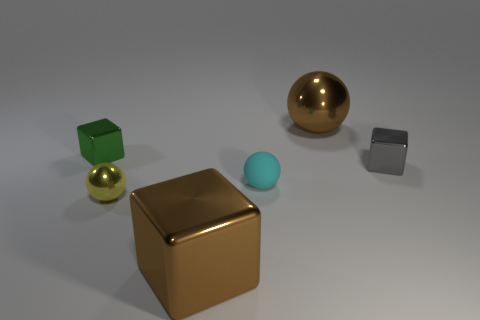Is the number of green cubes that are in front of the small rubber object greater than the number of big red rubber cylinders?
Provide a short and direct response. No. The green object that is the same material as the small gray block is what size?
Your answer should be compact. Small. There is a big brown metal cube; are there any green metal things on the right side of it?
Keep it short and to the point. No. Is the tiny gray thing the same shape as the small green object?
Give a very brief answer. Yes. What is the size of the brown shiny object that is in front of the tiny shiny block on the right side of the large brown thing that is behind the brown block?
Give a very brief answer. Large. What is the tiny cyan object made of?
Your response must be concise. Rubber. The shiny thing that is the same color as the large block is what size?
Your answer should be very brief. Large. Do the green object and the big object in front of the tiny yellow object have the same shape?
Your answer should be compact. Yes. There is a block on the right side of the large brown metal thing that is behind the metal block that is in front of the matte ball; what is its material?
Your answer should be very brief. Metal. What number of cyan rubber things are there?
Your response must be concise. 1. 